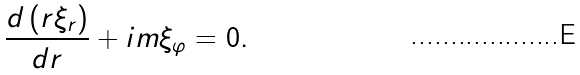<formula> <loc_0><loc_0><loc_500><loc_500>\frac { d \left ( r \xi _ { r } \right ) } { d r } + i m \xi _ { \varphi } = 0 .</formula> 